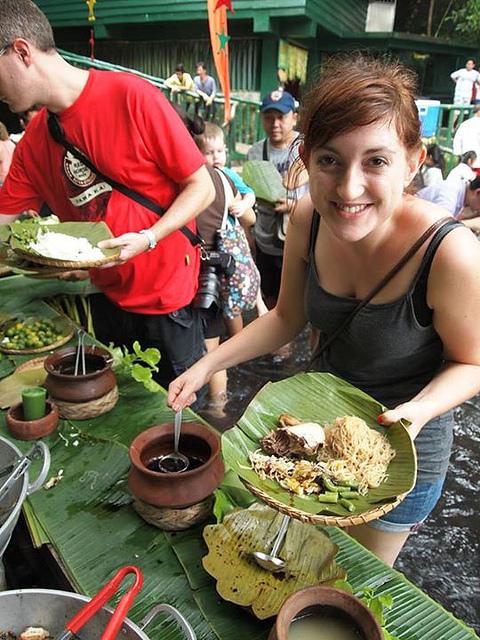Does the woman look happy or sad?
Answer briefly. Happy. Is the woman's burrito whole or half eaten?
Concise answer only. Half eaten. What type of leaf is lining the plates the people are holding?
Write a very short answer. Banana. 